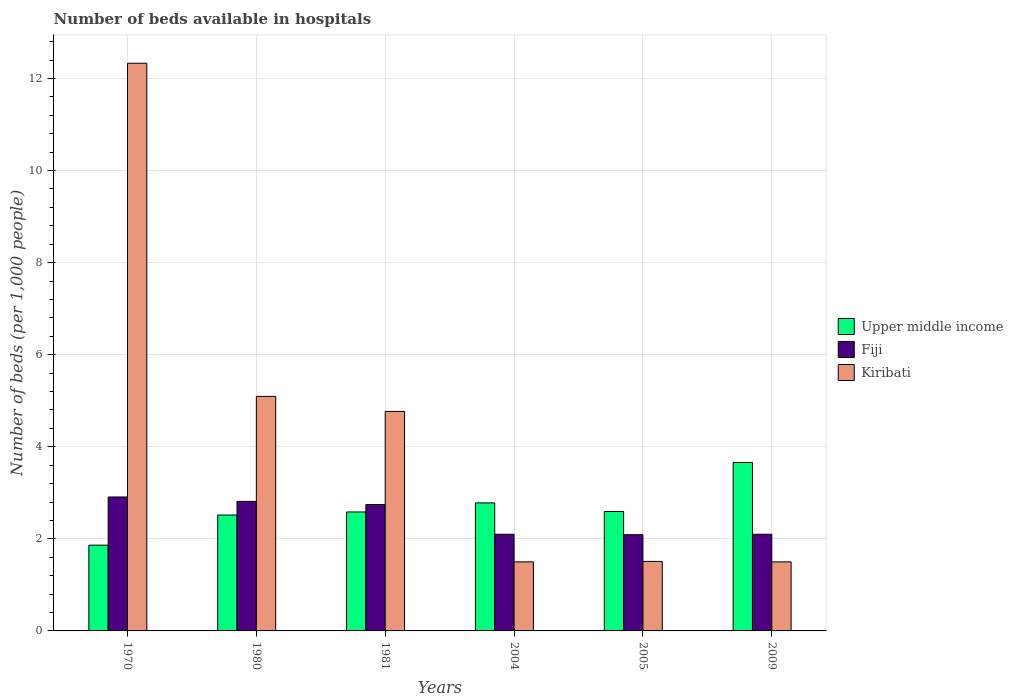How many groups of bars are there?
Ensure brevity in your answer.  6. Are the number of bars per tick equal to the number of legend labels?
Offer a very short reply. Yes. How many bars are there on the 1st tick from the left?
Ensure brevity in your answer.  3. In how many cases, is the number of bars for a given year not equal to the number of legend labels?
Provide a succinct answer. 0. What is the number of beds in the hospiatls of in Kiribati in 2009?
Give a very brief answer. 1.5. Across all years, what is the maximum number of beds in the hospiatls of in Upper middle income?
Offer a terse response. 3.66. Across all years, what is the minimum number of beds in the hospiatls of in Upper middle income?
Make the answer very short. 1.86. In which year was the number of beds in the hospiatls of in Upper middle income minimum?
Your response must be concise. 1970. What is the total number of beds in the hospiatls of in Kiribati in the graph?
Make the answer very short. 26.7. What is the difference between the number of beds in the hospiatls of in Fiji in 1970 and that in 1981?
Your response must be concise. 0.16. What is the difference between the number of beds in the hospiatls of in Kiribati in 2005 and the number of beds in the hospiatls of in Fiji in 1980?
Provide a short and direct response. -1.3. What is the average number of beds in the hospiatls of in Kiribati per year?
Make the answer very short. 4.45. In the year 2009, what is the difference between the number of beds in the hospiatls of in Upper middle income and number of beds in the hospiatls of in Fiji?
Offer a terse response. 1.56. What is the ratio of the number of beds in the hospiatls of in Upper middle income in 1980 to that in 2009?
Keep it short and to the point. 0.69. Is the number of beds in the hospiatls of in Fiji in 1981 less than that in 2009?
Your response must be concise. No. What is the difference between the highest and the second highest number of beds in the hospiatls of in Upper middle income?
Ensure brevity in your answer.  0.88. What is the difference between the highest and the lowest number of beds in the hospiatls of in Fiji?
Keep it short and to the point. 0.82. What does the 1st bar from the left in 2004 represents?
Offer a terse response. Upper middle income. What does the 3rd bar from the right in 2004 represents?
Give a very brief answer. Upper middle income. Is it the case that in every year, the sum of the number of beds in the hospiatls of in Upper middle income and number of beds in the hospiatls of in Fiji is greater than the number of beds in the hospiatls of in Kiribati?
Keep it short and to the point. No. What is the difference between two consecutive major ticks on the Y-axis?
Your response must be concise. 2. Are the values on the major ticks of Y-axis written in scientific E-notation?
Ensure brevity in your answer.  No. Does the graph contain any zero values?
Your answer should be compact. No. Does the graph contain grids?
Offer a terse response. Yes. What is the title of the graph?
Your response must be concise. Number of beds available in hospitals. Does "Bahrain" appear as one of the legend labels in the graph?
Make the answer very short. No. What is the label or title of the Y-axis?
Ensure brevity in your answer.  Number of beds (per 1,0 people). What is the Number of beds (per 1,000 people) in Upper middle income in 1970?
Provide a succinct answer. 1.86. What is the Number of beds (per 1,000 people) in Fiji in 1970?
Offer a very short reply. 2.91. What is the Number of beds (per 1,000 people) in Kiribati in 1970?
Offer a very short reply. 12.33. What is the Number of beds (per 1,000 people) of Upper middle income in 1980?
Provide a succinct answer. 2.52. What is the Number of beds (per 1,000 people) in Fiji in 1980?
Offer a terse response. 2.81. What is the Number of beds (per 1,000 people) in Kiribati in 1980?
Keep it short and to the point. 5.09. What is the Number of beds (per 1,000 people) of Upper middle income in 1981?
Ensure brevity in your answer.  2.58. What is the Number of beds (per 1,000 people) of Fiji in 1981?
Keep it short and to the point. 2.75. What is the Number of beds (per 1,000 people) in Kiribati in 1981?
Ensure brevity in your answer.  4.77. What is the Number of beds (per 1,000 people) in Upper middle income in 2004?
Provide a succinct answer. 2.78. What is the Number of beds (per 1,000 people) of Kiribati in 2004?
Your answer should be compact. 1.5. What is the Number of beds (per 1,000 people) in Upper middle income in 2005?
Make the answer very short. 2.59. What is the Number of beds (per 1,000 people) of Fiji in 2005?
Provide a succinct answer. 2.09. What is the Number of beds (per 1,000 people) of Kiribati in 2005?
Make the answer very short. 1.51. What is the Number of beds (per 1,000 people) in Upper middle income in 2009?
Ensure brevity in your answer.  3.66. What is the Number of beds (per 1,000 people) of Fiji in 2009?
Provide a short and direct response. 2.1. What is the Number of beds (per 1,000 people) in Kiribati in 2009?
Give a very brief answer. 1.5. Across all years, what is the maximum Number of beds (per 1,000 people) in Upper middle income?
Offer a very short reply. 3.66. Across all years, what is the maximum Number of beds (per 1,000 people) in Fiji?
Make the answer very short. 2.91. Across all years, what is the maximum Number of beds (per 1,000 people) in Kiribati?
Offer a very short reply. 12.33. Across all years, what is the minimum Number of beds (per 1,000 people) in Upper middle income?
Provide a succinct answer. 1.86. Across all years, what is the minimum Number of beds (per 1,000 people) in Fiji?
Your answer should be very brief. 2.09. What is the total Number of beds (per 1,000 people) of Upper middle income in the graph?
Make the answer very short. 16. What is the total Number of beds (per 1,000 people) of Fiji in the graph?
Keep it short and to the point. 14.76. What is the total Number of beds (per 1,000 people) in Kiribati in the graph?
Make the answer very short. 26.7. What is the difference between the Number of beds (per 1,000 people) of Upper middle income in 1970 and that in 1980?
Keep it short and to the point. -0.65. What is the difference between the Number of beds (per 1,000 people) in Fiji in 1970 and that in 1980?
Offer a terse response. 0.1. What is the difference between the Number of beds (per 1,000 people) in Kiribati in 1970 and that in 1980?
Offer a very short reply. 7.24. What is the difference between the Number of beds (per 1,000 people) in Upper middle income in 1970 and that in 1981?
Ensure brevity in your answer.  -0.72. What is the difference between the Number of beds (per 1,000 people) of Fiji in 1970 and that in 1981?
Your answer should be very brief. 0.16. What is the difference between the Number of beds (per 1,000 people) of Kiribati in 1970 and that in 1981?
Make the answer very short. 7.56. What is the difference between the Number of beds (per 1,000 people) of Upper middle income in 1970 and that in 2004?
Offer a very short reply. -0.92. What is the difference between the Number of beds (per 1,000 people) in Fiji in 1970 and that in 2004?
Make the answer very short. 0.81. What is the difference between the Number of beds (per 1,000 people) in Kiribati in 1970 and that in 2004?
Offer a terse response. 10.83. What is the difference between the Number of beds (per 1,000 people) of Upper middle income in 1970 and that in 2005?
Your response must be concise. -0.73. What is the difference between the Number of beds (per 1,000 people) in Fiji in 1970 and that in 2005?
Your response must be concise. 0.82. What is the difference between the Number of beds (per 1,000 people) of Kiribati in 1970 and that in 2005?
Keep it short and to the point. 10.82. What is the difference between the Number of beds (per 1,000 people) in Upper middle income in 1970 and that in 2009?
Make the answer very short. -1.8. What is the difference between the Number of beds (per 1,000 people) of Fiji in 1970 and that in 2009?
Offer a very short reply. 0.81. What is the difference between the Number of beds (per 1,000 people) in Kiribati in 1970 and that in 2009?
Offer a very short reply. 10.83. What is the difference between the Number of beds (per 1,000 people) in Upper middle income in 1980 and that in 1981?
Make the answer very short. -0.07. What is the difference between the Number of beds (per 1,000 people) of Fiji in 1980 and that in 1981?
Provide a short and direct response. 0.07. What is the difference between the Number of beds (per 1,000 people) of Kiribati in 1980 and that in 1981?
Your answer should be very brief. 0.33. What is the difference between the Number of beds (per 1,000 people) in Upper middle income in 1980 and that in 2004?
Provide a succinct answer. -0.26. What is the difference between the Number of beds (per 1,000 people) of Fiji in 1980 and that in 2004?
Ensure brevity in your answer.  0.71. What is the difference between the Number of beds (per 1,000 people) of Kiribati in 1980 and that in 2004?
Your response must be concise. 3.59. What is the difference between the Number of beds (per 1,000 people) in Upper middle income in 1980 and that in 2005?
Provide a succinct answer. -0.08. What is the difference between the Number of beds (per 1,000 people) of Fiji in 1980 and that in 2005?
Make the answer very short. 0.72. What is the difference between the Number of beds (per 1,000 people) of Kiribati in 1980 and that in 2005?
Provide a succinct answer. 3.58. What is the difference between the Number of beds (per 1,000 people) of Upper middle income in 1980 and that in 2009?
Your response must be concise. -1.14. What is the difference between the Number of beds (per 1,000 people) in Fiji in 1980 and that in 2009?
Offer a very short reply. 0.71. What is the difference between the Number of beds (per 1,000 people) in Kiribati in 1980 and that in 2009?
Offer a very short reply. 3.59. What is the difference between the Number of beds (per 1,000 people) in Upper middle income in 1981 and that in 2004?
Your response must be concise. -0.2. What is the difference between the Number of beds (per 1,000 people) of Fiji in 1981 and that in 2004?
Offer a very short reply. 0.65. What is the difference between the Number of beds (per 1,000 people) in Kiribati in 1981 and that in 2004?
Provide a succinct answer. 3.27. What is the difference between the Number of beds (per 1,000 people) of Upper middle income in 1981 and that in 2005?
Provide a short and direct response. -0.01. What is the difference between the Number of beds (per 1,000 people) in Fiji in 1981 and that in 2005?
Give a very brief answer. 0.66. What is the difference between the Number of beds (per 1,000 people) of Kiribati in 1981 and that in 2005?
Offer a very short reply. 3.26. What is the difference between the Number of beds (per 1,000 people) of Upper middle income in 1981 and that in 2009?
Your answer should be compact. -1.07. What is the difference between the Number of beds (per 1,000 people) of Fiji in 1981 and that in 2009?
Offer a very short reply. 0.65. What is the difference between the Number of beds (per 1,000 people) in Kiribati in 1981 and that in 2009?
Offer a terse response. 3.27. What is the difference between the Number of beds (per 1,000 people) of Upper middle income in 2004 and that in 2005?
Provide a short and direct response. 0.19. What is the difference between the Number of beds (per 1,000 people) of Fiji in 2004 and that in 2005?
Your response must be concise. 0.01. What is the difference between the Number of beds (per 1,000 people) in Kiribati in 2004 and that in 2005?
Your answer should be compact. -0.01. What is the difference between the Number of beds (per 1,000 people) in Upper middle income in 2004 and that in 2009?
Ensure brevity in your answer.  -0.88. What is the difference between the Number of beds (per 1,000 people) of Fiji in 2004 and that in 2009?
Your answer should be compact. 0. What is the difference between the Number of beds (per 1,000 people) in Upper middle income in 2005 and that in 2009?
Your answer should be very brief. -1.07. What is the difference between the Number of beds (per 1,000 people) in Fiji in 2005 and that in 2009?
Ensure brevity in your answer.  -0.01. What is the difference between the Number of beds (per 1,000 people) in Upper middle income in 1970 and the Number of beds (per 1,000 people) in Fiji in 1980?
Offer a terse response. -0.95. What is the difference between the Number of beds (per 1,000 people) of Upper middle income in 1970 and the Number of beds (per 1,000 people) of Kiribati in 1980?
Offer a terse response. -3.23. What is the difference between the Number of beds (per 1,000 people) of Fiji in 1970 and the Number of beds (per 1,000 people) of Kiribati in 1980?
Offer a very short reply. -2.19. What is the difference between the Number of beds (per 1,000 people) in Upper middle income in 1970 and the Number of beds (per 1,000 people) in Fiji in 1981?
Your response must be concise. -0.88. What is the difference between the Number of beds (per 1,000 people) in Upper middle income in 1970 and the Number of beds (per 1,000 people) in Kiribati in 1981?
Provide a succinct answer. -2.91. What is the difference between the Number of beds (per 1,000 people) of Fiji in 1970 and the Number of beds (per 1,000 people) of Kiribati in 1981?
Your response must be concise. -1.86. What is the difference between the Number of beds (per 1,000 people) in Upper middle income in 1970 and the Number of beds (per 1,000 people) in Fiji in 2004?
Your response must be concise. -0.24. What is the difference between the Number of beds (per 1,000 people) in Upper middle income in 1970 and the Number of beds (per 1,000 people) in Kiribati in 2004?
Your response must be concise. 0.36. What is the difference between the Number of beds (per 1,000 people) of Fiji in 1970 and the Number of beds (per 1,000 people) of Kiribati in 2004?
Offer a terse response. 1.41. What is the difference between the Number of beds (per 1,000 people) in Upper middle income in 1970 and the Number of beds (per 1,000 people) in Fiji in 2005?
Provide a succinct answer. -0.23. What is the difference between the Number of beds (per 1,000 people) of Upper middle income in 1970 and the Number of beds (per 1,000 people) of Kiribati in 2005?
Your response must be concise. 0.35. What is the difference between the Number of beds (per 1,000 people) of Fiji in 1970 and the Number of beds (per 1,000 people) of Kiribati in 2005?
Your response must be concise. 1.4. What is the difference between the Number of beds (per 1,000 people) in Upper middle income in 1970 and the Number of beds (per 1,000 people) in Fiji in 2009?
Provide a succinct answer. -0.24. What is the difference between the Number of beds (per 1,000 people) in Upper middle income in 1970 and the Number of beds (per 1,000 people) in Kiribati in 2009?
Provide a short and direct response. 0.36. What is the difference between the Number of beds (per 1,000 people) in Fiji in 1970 and the Number of beds (per 1,000 people) in Kiribati in 2009?
Your response must be concise. 1.41. What is the difference between the Number of beds (per 1,000 people) of Upper middle income in 1980 and the Number of beds (per 1,000 people) of Fiji in 1981?
Ensure brevity in your answer.  -0.23. What is the difference between the Number of beds (per 1,000 people) in Upper middle income in 1980 and the Number of beds (per 1,000 people) in Kiribati in 1981?
Provide a succinct answer. -2.25. What is the difference between the Number of beds (per 1,000 people) of Fiji in 1980 and the Number of beds (per 1,000 people) of Kiribati in 1981?
Your answer should be very brief. -1.95. What is the difference between the Number of beds (per 1,000 people) in Upper middle income in 1980 and the Number of beds (per 1,000 people) in Fiji in 2004?
Offer a terse response. 0.42. What is the difference between the Number of beds (per 1,000 people) of Upper middle income in 1980 and the Number of beds (per 1,000 people) of Kiribati in 2004?
Ensure brevity in your answer.  1.02. What is the difference between the Number of beds (per 1,000 people) of Fiji in 1980 and the Number of beds (per 1,000 people) of Kiribati in 2004?
Ensure brevity in your answer.  1.31. What is the difference between the Number of beds (per 1,000 people) of Upper middle income in 1980 and the Number of beds (per 1,000 people) of Fiji in 2005?
Give a very brief answer. 0.43. What is the difference between the Number of beds (per 1,000 people) in Upper middle income in 1980 and the Number of beds (per 1,000 people) in Kiribati in 2005?
Offer a very short reply. 1.01. What is the difference between the Number of beds (per 1,000 people) in Fiji in 1980 and the Number of beds (per 1,000 people) in Kiribati in 2005?
Your response must be concise. 1.3. What is the difference between the Number of beds (per 1,000 people) of Upper middle income in 1980 and the Number of beds (per 1,000 people) of Fiji in 2009?
Ensure brevity in your answer.  0.42. What is the difference between the Number of beds (per 1,000 people) in Upper middle income in 1980 and the Number of beds (per 1,000 people) in Kiribati in 2009?
Your answer should be very brief. 1.02. What is the difference between the Number of beds (per 1,000 people) of Fiji in 1980 and the Number of beds (per 1,000 people) of Kiribati in 2009?
Keep it short and to the point. 1.31. What is the difference between the Number of beds (per 1,000 people) of Upper middle income in 1981 and the Number of beds (per 1,000 people) of Fiji in 2004?
Keep it short and to the point. 0.48. What is the difference between the Number of beds (per 1,000 people) in Upper middle income in 1981 and the Number of beds (per 1,000 people) in Kiribati in 2004?
Make the answer very short. 1.08. What is the difference between the Number of beds (per 1,000 people) in Fiji in 1981 and the Number of beds (per 1,000 people) in Kiribati in 2004?
Your answer should be very brief. 1.25. What is the difference between the Number of beds (per 1,000 people) of Upper middle income in 1981 and the Number of beds (per 1,000 people) of Fiji in 2005?
Offer a very short reply. 0.49. What is the difference between the Number of beds (per 1,000 people) in Upper middle income in 1981 and the Number of beds (per 1,000 people) in Kiribati in 2005?
Ensure brevity in your answer.  1.07. What is the difference between the Number of beds (per 1,000 people) in Fiji in 1981 and the Number of beds (per 1,000 people) in Kiribati in 2005?
Ensure brevity in your answer.  1.24. What is the difference between the Number of beds (per 1,000 people) of Upper middle income in 1981 and the Number of beds (per 1,000 people) of Fiji in 2009?
Your answer should be very brief. 0.48. What is the difference between the Number of beds (per 1,000 people) of Upper middle income in 1981 and the Number of beds (per 1,000 people) of Kiribati in 2009?
Provide a succinct answer. 1.08. What is the difference between the Number of beds (per 1,000 people) of Fiji in 1981 and the Number of beds (per 1,000 people) of Kiribati in 2009?
Make the answer very short. 1.25. What is the difference between the Number of beds (per 1,000 people) of Upper middle income in 2004 and the Number of beds (per 1,000 people) of Fiji in 2005?
Make the answer very short. 0.69. What is the difference between the Number of beds (per 1,000 people) in Upper middle income in 2004 and the Number of beds (per 1,000 people) in Kiribati in 2005?
Offer a terse response. 1.27. What is the difference between the Number of beds (per 1,000 people) of Fiji in 2004 and the Number of beds (per 1,000 people) of Kiribati in 2005?
Provide a succinct answer. 0.59. What is the difference between the Number of beds (per 1,000 people) in Upper middle income in 2004 and the Number of beds (per 1,000 people) in Fiji in 2009?
Keep it short and to the point. 0.68. What is the difference between the Number of beds (per 1,000 people) of Upper middle income in 2004 and the Number of beds (per 1,000 people) of Kiribati in 2009?
Ensure brevity in your answer.  1.28. What is the difference between the Number of beds (per 1,000 people) in Fiji in 2004 and the Number of beds (per 1,000 people) in Kiribati in 2009?
Ensure brevity in your answer.  0.6. What is the difference between the Number of beds (per 1,000 people) of Upper middle income in 2005 and the Number of beds (per 1,000 people) of Fiji in 2009?
Offer a terse response. 0.49. What is the difference between the Number of beds (per 1,000 people) in Upper middle income in 2005 and the Number of beds (per 1,000 people) in Kiribati in 2009?
Your answer should be very brief. 1.09. What is the difference between the Number of beds (per 1,000 people) in Fiji in 2005 and the Number of beds (per 1,000 people) in Kiribati in 2009?
Provide a succinct answer. 0.59. What is the average Number of beds (per 1,000 people) in Upper middle income per year?
Give a very brief answer. 2.67. What is the average Number of beds (per 1,000 people) in Fiji per year?
Your response must be concise. 2.46. What is the average Number of beds (per 1,000 people) of Kiribati per year?
Give a very brief answer. 4.45. In the year 1970, what is the difference between the Number of beds (per 1,000 people) in Upper middle income and Number of beds (per 1,000 people) in Fiji?
Give a very brief answer. -1.05. In the year 1970, what is the difference between the Number of beds (per 1,000 people) of Upper middle income and Number of beds (per 1,000 people) of Kiribati?
Offer a terse response. -10.47. In the year 1970, what is the difference between the Number of beds (per 1,000 people) of Fiji and Number of beds (per 1,000 people) of Kiribati?
Make the answer very short. -9.42. In the year 1980, what is the difference between the Number of beds (per 1,000 people) of Upper middle income and Number of beds (per 1,000 people) of Fiji?
Offer a very short reply. -0.3. In the year 1980, what is the difference between the Number of beds (per 1,000 people) in Upper middle income and Number of beds (per 1,000 people) in Kiribati?
Your answer should be compact. -2.58. In the year 1980, what is the difference between the Number of beds (per 1,000 people) of Fiji and Number of beds (per 1,000 people) of Kiribati?
Give a very brief answer. -2.28. In the year 1981, what is the difference between the Number of beds (per 1,000 people) in Upper middle income and Number of beds (per 1,000 people) in Fiji?
Your answer should be very brief. -0.16. In the year 1981, what is the difference between the Number of beds (per 1,000 people) of Upper middle income and Number of beds (per 1,000 people) of Kiribati?
Your response must be concise. -2.18. In the year 1981, what is the difference between the Number of beds (per 1,000 people) in Fiji and Number of beds (per 1,000 people) in Kiribati?
Ensure brevity in your answer.  -2.02. In the year 2004, what is the difference between the Number of beds (per 1,000 people) of Upper middle income and Number of beds (per 1,000 people) of Fiji?
Provide a short and direct response. 0.68. In the year 2004, what is the difference between the Number of beds (per 1,000 people) in Upper middle income and Number of beds (per 1,000 people) in Kiribati?
Make the answer very short. 1.28. In the year 2005, what is the difference between the Number of beds (per 1,000 people) in Upper middle income and Number of beds (per 1,000 people) in Fiji?
Your response must be concise. 0.5. In the year 2005, what is the difference between the Number of beds (per 1,000 people) of Upper middle income and Number of beds (per 1,000 people) of Kiribati?
Keep it short and to the point. 1.08. In the year 2005, what is the difference between the Number of beds (per 1,000 people) of Fiji and Number of beds (per 1,000 people) of Kiribati?
Keep it short and to the point. 0.58. In the year 2009, what is the difference between the Number of beds (per 1,000 people) of Upper middle income and Number of beds (per 1,000 people) of Fiji?
Offer a terse response. 1.56. In the year 2009, what is the difference between the Number of beds (per 1,000 people) of Upper middle income and Number of beds (per 1,000 people) of Kiribati?
Your answer should be compact. 2.16. What is the ratio of the Number of beds (per 1,000 people) of Upper middle income in 1970 to that in 1980?
Offer a very short reply. 0.74. What is the ratio of the Number of beds (per 1,000 people) of Fiji in 1970 to that in 1980?
Your response must be concise. 1.03. What is the ratio of the Number of beds (per 1,000 people) of Kiribati in 1970 to that in 1980?
Ensure brevity in your answer.  2.42. What is the ratio of the Number of beds (per 1,000 people) in Upper middle income in 1970 to that in 1981?
Your response must be concise. 0.72. What is the ratio of the Number of beds (per 1,000 people) in Fiji in 1970 to that in 1981?
Provide a succinct answer. 1.06. What is the ratio of the Number of beds (per 1,000 people) in Kiribati in 1970 to that in 1981?
Ensure brevity in your answer.  2.59. What is the ratio of the Number of beds (per 1,000 people) in Upper middle income in 1970 to that in 2004?
Give a very brief answer. 0.67. What is the ratio of the Number of beds (per 1,000 people) in Fiji in 1970 to that in 2004?
Provide a succinct answer. 1.39. What is the ratio of the Number of beds (per 1,000 people) in Kiribati in 1970 to that in 2004?
Your response must be concise. 8.22. What is the ratio of the Number of beds (per 1,000 people) in Upper middle income in 1970 to that in 2005?
Give a very brief answer. 0.72. What is the ratio of the Number of beds (per 1,000 people) of Fiji in 1970 to that in 2005?
Your answer should be compact. 1.39. What is the ratio of the Number of beds (per 1,000 people) of Kiribati in 1970 to that in 2005?
Ensure brevity in your answer.  8.17. What is the ratio of the Number of beds (per 1,000 people) of Upper middle income in 1970 to that in 2009?
Your answer should be very brief. 0.51. What is the ratio of the Number of beds (per 1,000 people) of Fiji in 1970 to that in 2009?
Ensure brevity in your answer.  1.39. What is the ratio of the Number of beds (per 1,000 people) in Kiribati in 1970 to that in 2009?
Make the answer very short. 8.22. What is the ratio of the Number of beds (per 1,000 people) of Upper middle income in 1980 to that in 1981?
Make the answer very short. 0.97. What is the ratio of the Number of beds (per 1,000 people) of Fiji in 1980 to that in 1981?
Offer a terse response. 1.02. What is the ratio of the Number of beds (per 1,000 people) of Kiribati in 1980 to that in 1981?
Ensure brevity in your answer.  1.07. What is the ratio of the Number of beds (per 1,000 people) of Upper middle income in 1980 to that in 2004?
Your answer should be very brief. 0.91. What is the ratio of the Number of beds (per 1,000 people) of Fiji in 1980 to that in 2004?
Keep it short and to the point. 1.34. What is the ratio of the Number of beds (per 1,000 people) of Kiribati in 1980 to that in 2004?
Keep it short and to the point. 3.4. What is the ratio of the Number of beds (per 1,000 people) of Upper middle income in 1980 to that in 2005?
Make the answer very short. 0.97. What is the ratio of the Number of beds (per 1,000 people) of Fiji in 1980 to that in 2005?
Offer a terse response. 1.35. What is the ratio of the Number of beds (per 1,000 people) of Kiribati in 1980 to that in 2005?
Offer a terse response. 3.37. What is the ratio of the Number of beds (per 1,000 people) of Upper middle income in 1980 to that in 2009?
Offer a terse response. 0.69. What is the ratio of the Number of beds (per 1,000 people) of Fiji in 1980 to that in 2009?
Your answer should be compact. 1.34. What is the ratio of the Number of beds (per 1,000 people) of Kiribati in 1980 to that in 2009?
Your answer should be very brief. 3.4. What is the ratio of the Number of beds (per 1,000 people) in Upper middle income in 1981 to that in 2004?
Provide a short and direct response. 0.93. What is the ratio of the Number of beds (per 1,000 people) in Fiji in 1981 to that in 2004?
Make the answer very short. 1.31. What is the ratio of the Number of beds (per 1,000 people) of Kiribati in 1981 to that in 2004?
Ensure brevity in your answer.  3.18. What is the ratio of the Number of beds (per 1,000 people) of Fiji in 1981 to that in 2005?
Provide a short and direct response. 1.31. What is the ratio of the Number of beds (per 1,000 people) in Kiribati in 1981 to that in 2005?
Your answer should be compact. 3.16. What is the ratio of the Number of beds (per 1,000 people) of Upper middle income in 1981 to that in 2009?
Offer a terse response. 0.71. What is the ratio of the Number of beds (per 1,000 people) in Fiji in 1981 to that in 2009?
Your answer should be very brief. 1.31. What is the ratio of the Number of beds (per 1,000 people) in Kiribati in 1981 to that in 2009?
Make the answer very short. 3.18. What is the ratio of the Number of beds (per 1,000 people) of Upper middle income in 2004 to that in 2005?
Give a very brief answer. 1.07. What is the ratio of the Number of beds (per 1,000 people) in Upper middle income in 2004 to that in 2009?
Provide a short and direct response. 0.76. What is the ratio of the Number of beds (per 1,000 people) of Kiribati in 2004 to that in 2009?
Offer a terse response. 1. What is the ratio of the Number of beds (per 1,000 people) in Upper middle income in 2005 to that in 2009?
Give a very brief answer. 0.71. What is the ratio of the Number of beds (per 1,000 people) in Kiribati in 2005 to that in 2009?
Your response must be concise. 1.01. What is the difference between the highest and the second highest Number of beds (per 1,000 people) in Upper middle income?
Make the answer very short. 0.88. What is the difference between the highest and the second highest Number of beds (per 1,000 people) of Fiji?
Keep it short and to the point. 0.1. What is the difference between the highest and the second highest Number of beds (per 1,000 people) of Kiribati?
Your answer should be compact. 7.24. What is the difference between the highest and the lowest Number of beds (per 1,000 people) in Upper middle income?
Make the answer very short. 1.8. What is the difference between the highest and the lowest Number of beds (per 1,000 people) of Fiji?
Your answer should be compact. 0.82. What is the difference between the highest and the lowest Number of beds (per 1,000 people) in Kiribati?
Ensure brevity in your answer.  10.83. 